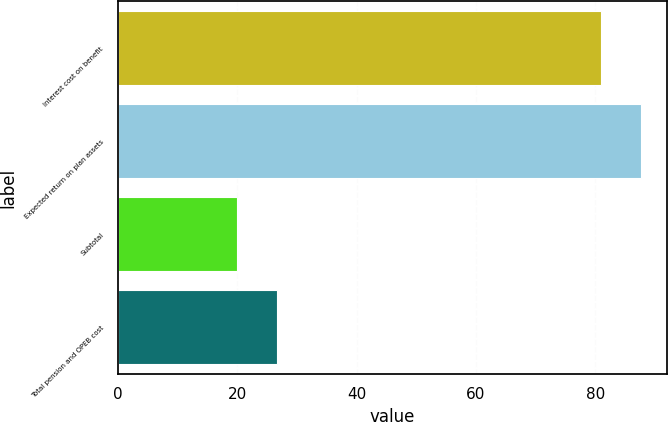<chart> <loc_0><loc_0><loc_500><loc_500><bar_chart><fcel>Interest cost on benefit<fcel>Expected return on plan assets<fcel>Subtotal<fcel>Total pension and OPEB cost<nl><fcel>81<fcel>87.6<fcel>20<fcel>26.6<nl></chart> 